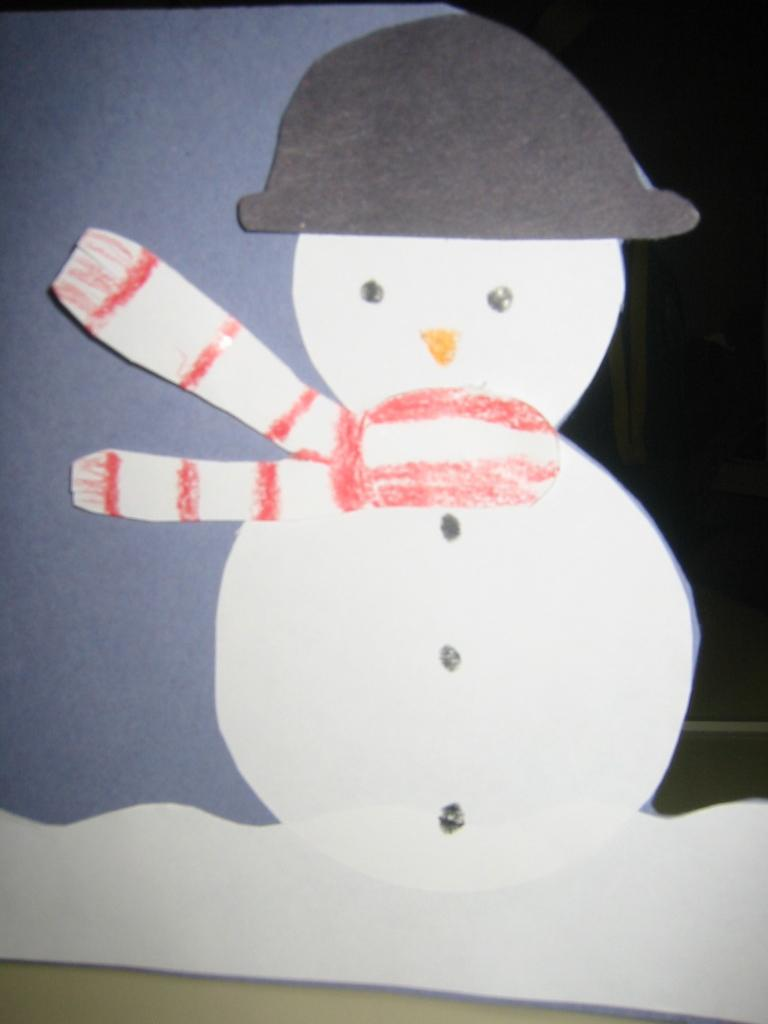What is the main subject of the image? There is a snowman in the image. What material is the snowman made of? The snowman is made with paper. What accessories is the snowman wearing? The snowman is wearing a hat and a muffler. Can you tell me what type of gold jewelry the snowman is wearing in the image? There is no gold jewelry present on the snowman in the image; it is made of paper and wearing a hat and a muffler. 